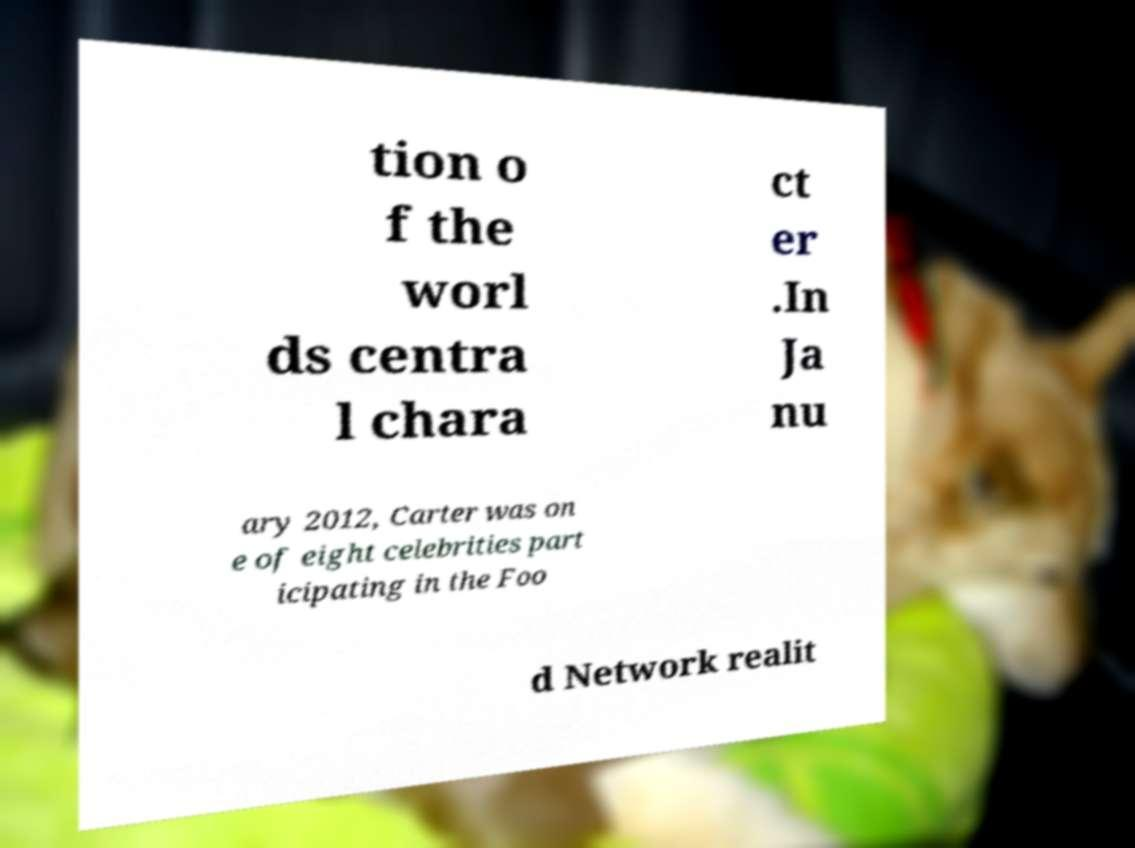Can you accurately transcribe the text from the provided image for me? tion o f the worl ds centra l chara ct er .In Ja nu ary 2012, Carter was on e of eight celebrities part icipating in the Foo d Network realit 